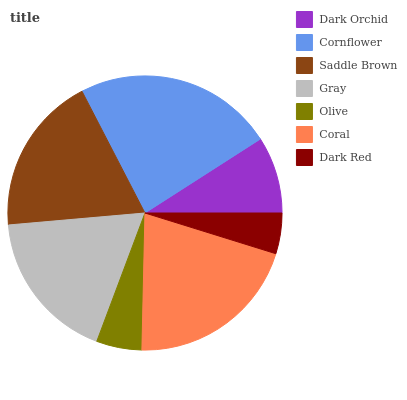Is Dark Red the minimum?
Answer yes or no. Yes. Is Cornflower the maximum?
Answer yes or no. Yes. Is Saddle Brown the minimum?
Answer yes or no. No. Is Saddle Brown the maximum?
Answer yes or no. No. Is Cornflower greater than Saddle Brown?
Answer yes or no. Yes. Is Saddle Brown less than Cornflower?
Answer yes or no. Yes. Is Saddle Brown greater than Cornflower?
Answer yes or no. No. Is Cornflower less than Saddle Brown?
Answer yes or no. No. Is Gray the high median?
Answer yes or no. Yes. Is Gray the low median?
Answer yes or no. Yes. Is Olive the high median?
Answer yes or no. No. Is Coral the low median?
Answer yes or no. No. 